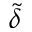Convert formula to latex. <formula><loc_0><loc_0><loc_500><loc_500>\tilde { \delta }</formula> 